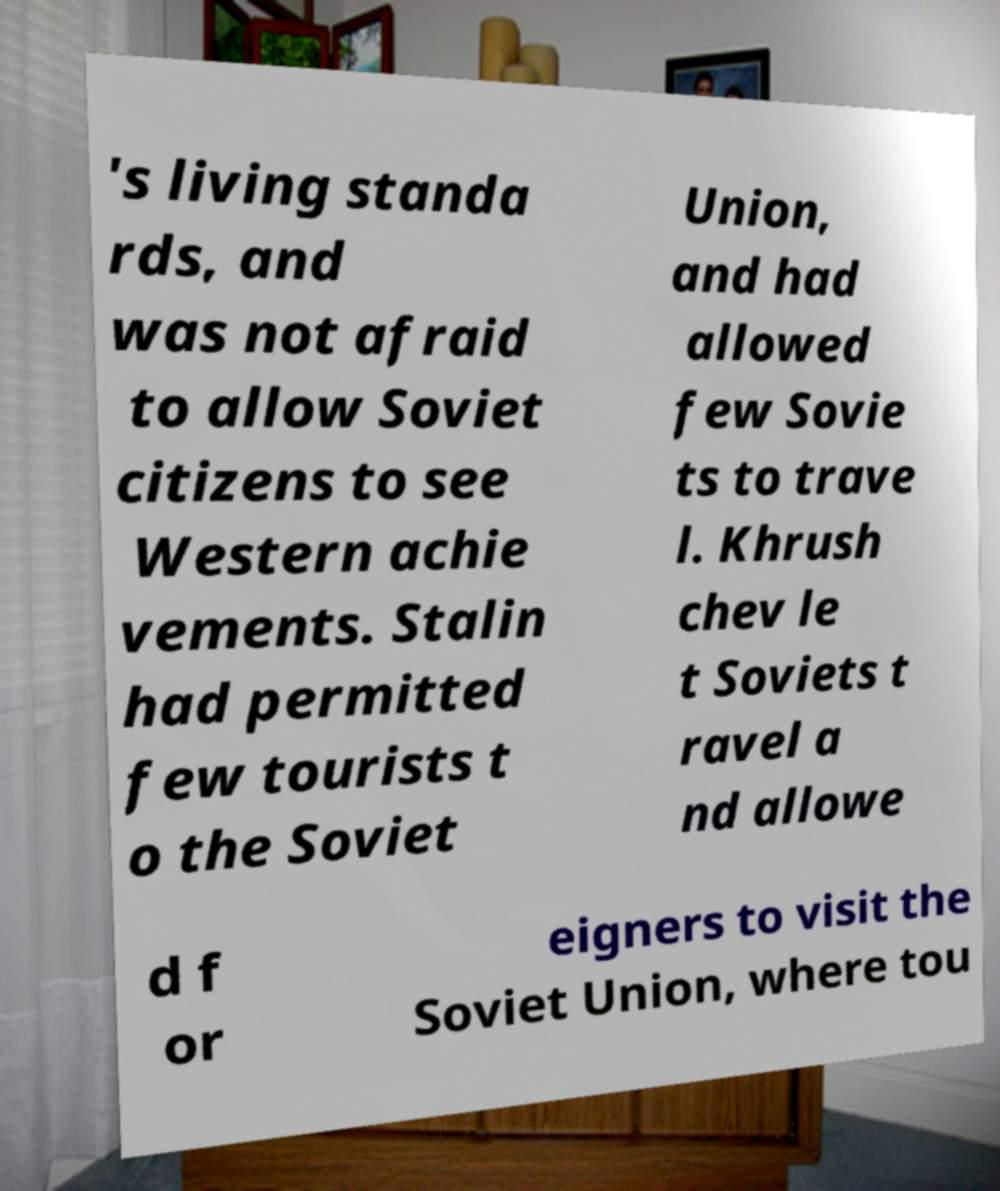Please read and relay the text visible in this image. What does it say? 's living standa rds, and was not afraid to allow Soviet citizens to see Western achie vements. Stalin had permitted few tourists t o the Soviet Union, and had allowed few Sovie ts to trave l. Khrush chev le t Soviets t ravel a nd allowe d f or eigners to visit the Soviet Union, where tou 